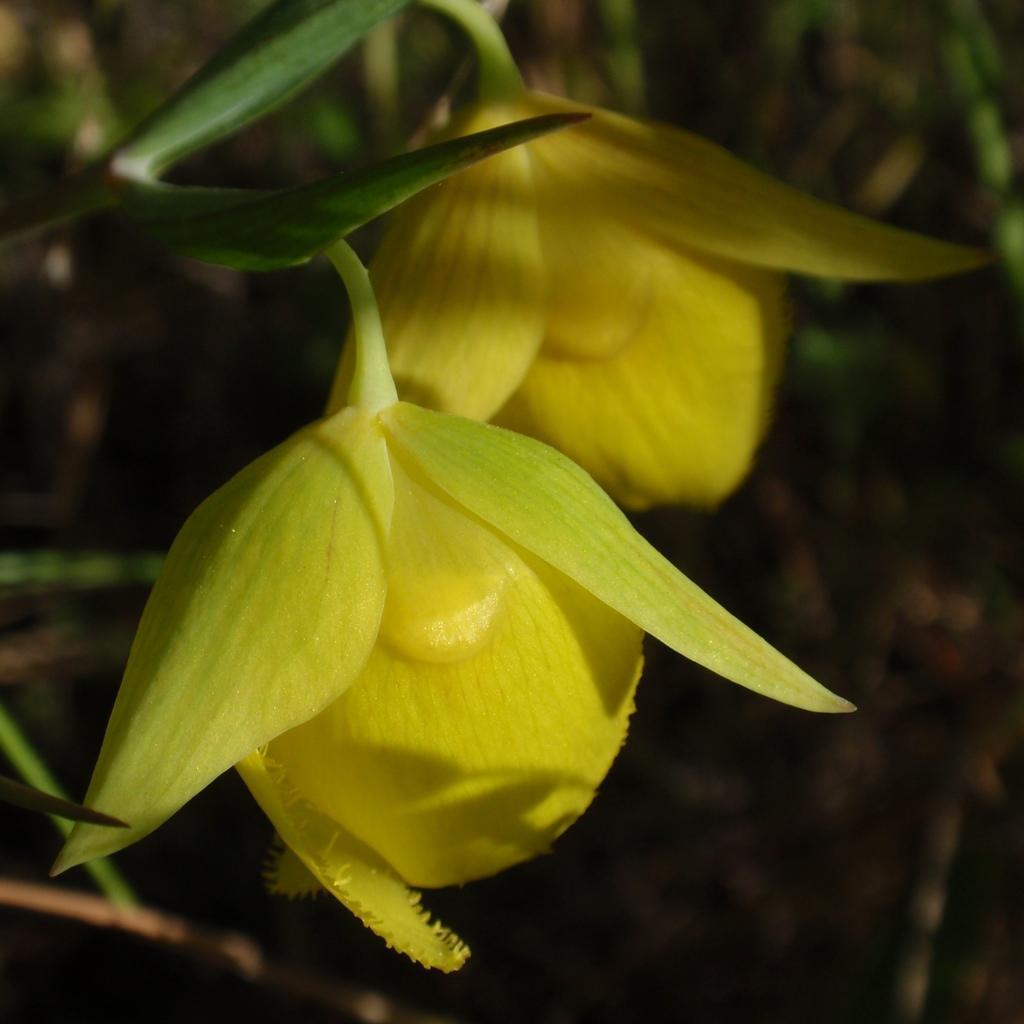Can you describe this image briefly? Here we can see yellow color flowers. There is a blur background. 